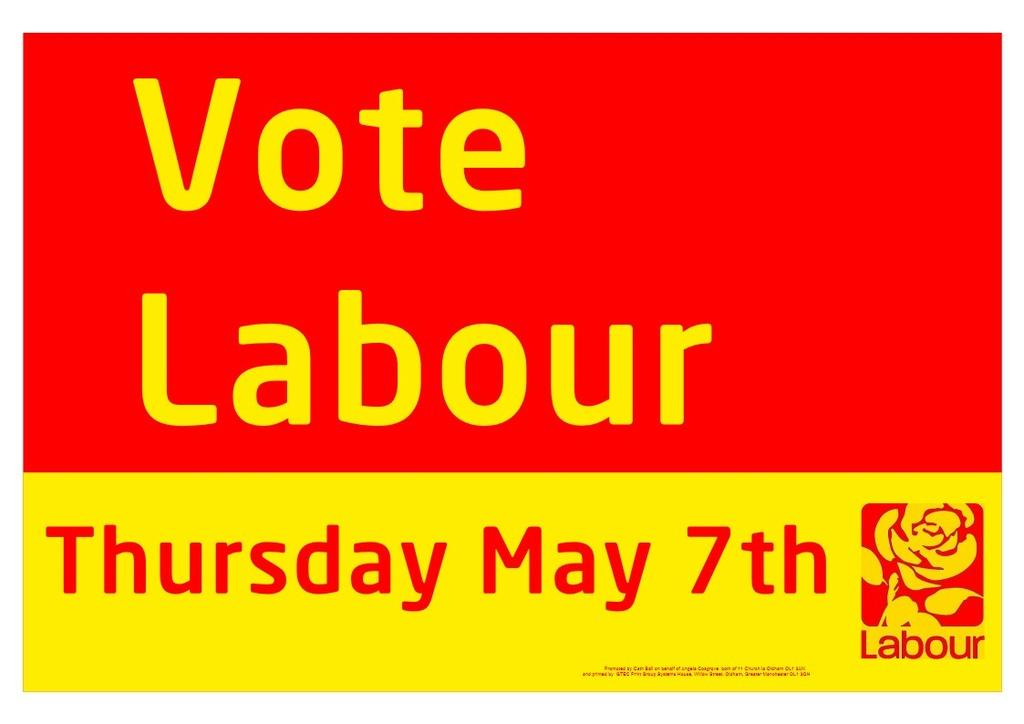Provide a one-sentence caption for the provided image. A red and yellow sign encourages people to vote labour. 